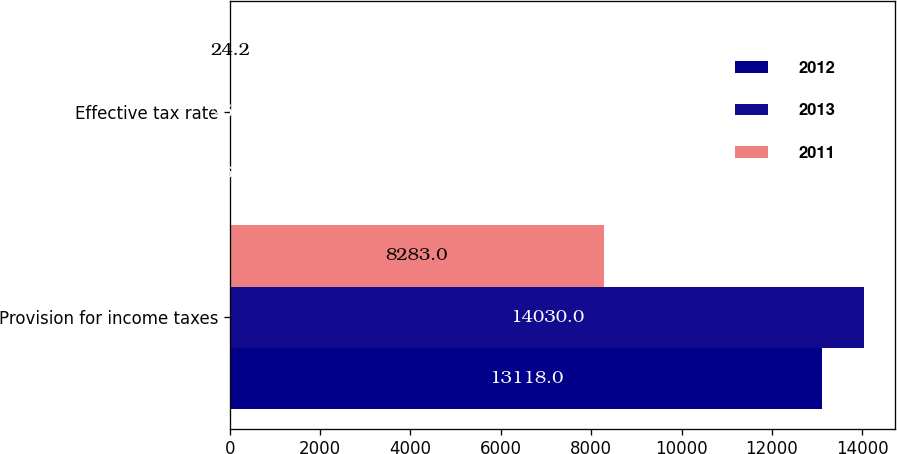Convert chart to OTSL. <chart><loc_0><loc_0><loc_500><loc_500><stacked_bar_chart><ecel><fcel>Provision for income taxes<fcel>Effective tax rate<nl><fcel>2012<fcel>13118<fcel>26.2<nl><fcel>2013<fcel>14030<fcel>25.2<nl><fcel>2011<fcel>8283<fcel>24.2<nl></chart> 